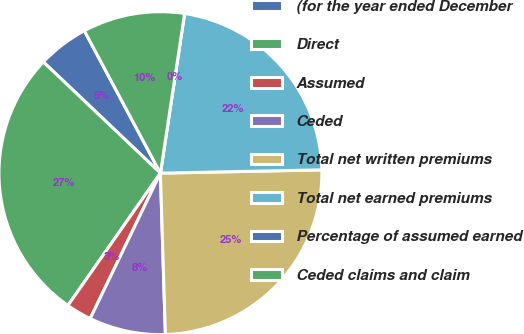Convert chart to OTSL. <chart><loc_0><loc_0><loc_500><loc_500><pie_chart><fcel>(for the year ended December<fcel>Direct<fcel>Assumed<fcel>Ceded<fcel>Total net written premiums<fcel>Total net earned premiums<fcel>Percentage of assumed earned<fcel>Ceded claims and claim<nl><fcel>5.1%<fcel>27.38%<fcel>2.55%<fcel>7.65%<fcel>24.83%<fcel>22.28%<fcel>0.0%<fcel>10.2%<nl></chart> 